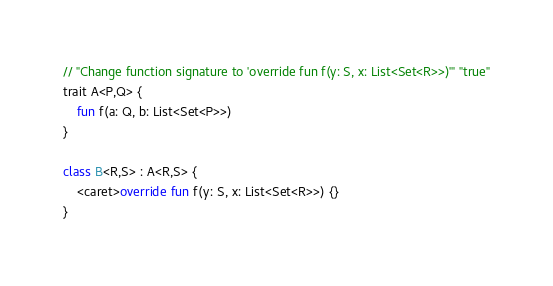Convert code to text. <code><loc_0><loc_0><loc_500><loc_500><_Kotlin_>// "Change function signature to 'override fun f(y: S, x: List<Set<R>>)'" "true"
trait A<P,Q> {
    fun f(a: Q, b: List<Set<P>>)
}

class B<R,S> : A<R,S> {
    <caret>override fun f(y: S, x: List<Set<R>>) {}
}
</code> 